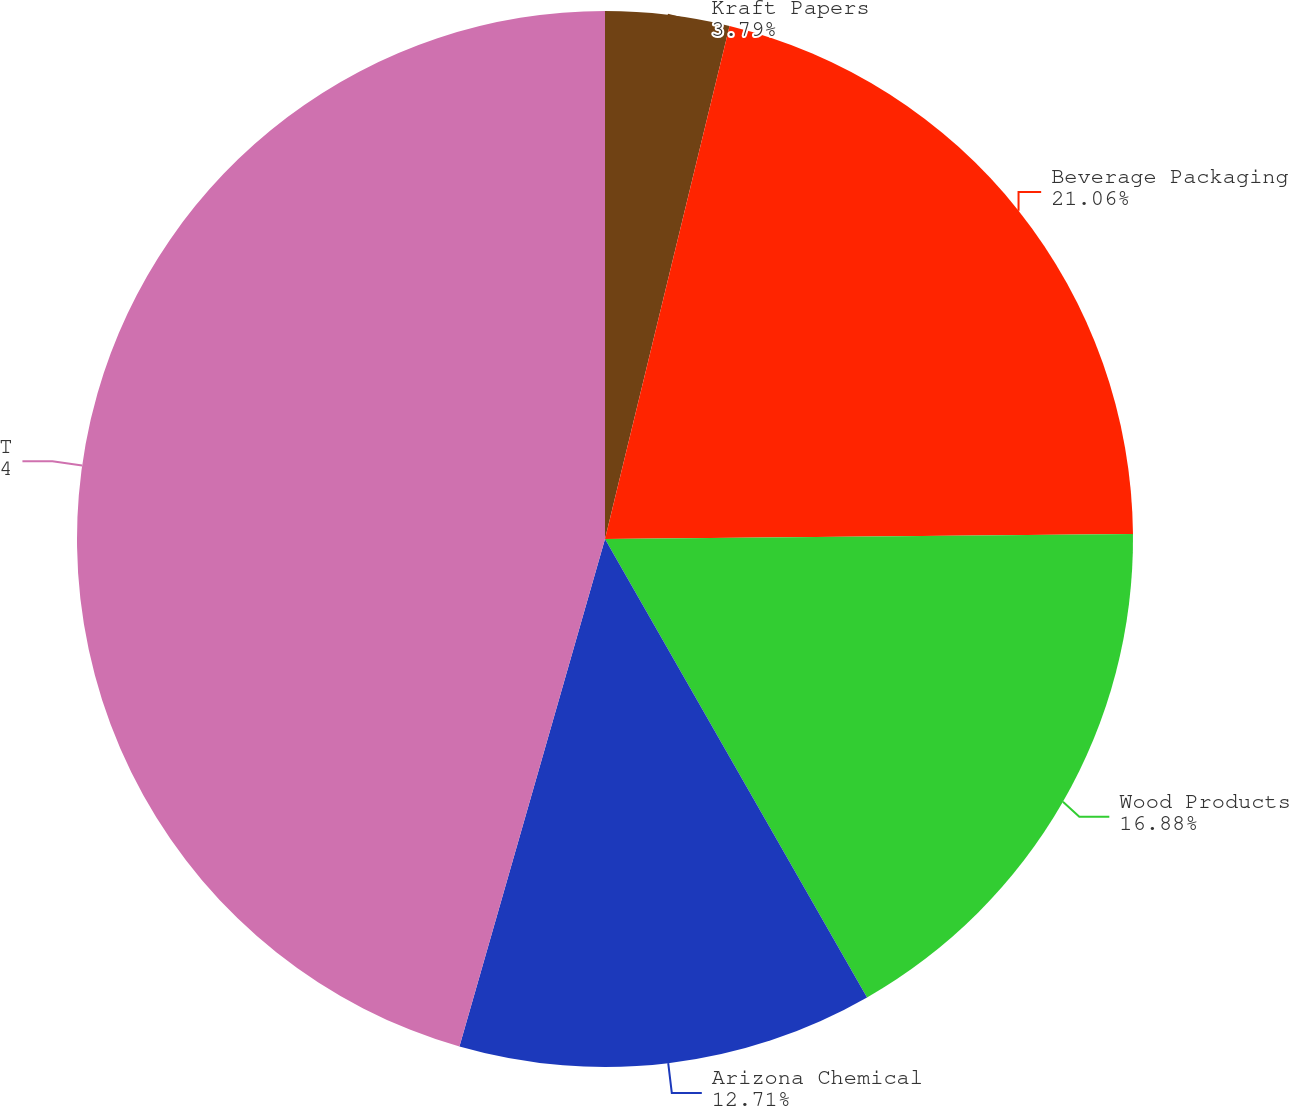<chart> <loc_0><loc_0><loc_500><loc_500><pie_chart><fcel>Kraft Papers<fcel>Beverage Packaging<fcel>Wood Products<fcel>Arizona Chemical<fcel>Totals<nl><fcel>3.79%<fcel>21.06%<fcel>16.88%<fcel>12.71%<fcel>45.55%<nl></chart> 